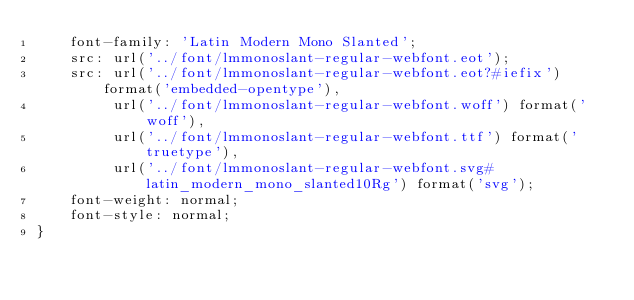Convert code to text. <code><loc_0><loc_0><loc_500><loc_500><_CSS_>    font-family: 'Latin Modern Mono Slanted';
    src: url('../font/lmmonoslant-regular-webfont.eot');
    src: url('../font/lmmonoslant-regular-webfont.eot?#iefix') format('embedded-opentype'),
         url('../font/lmmonoslant-regular-webfont.woff') format('woff'),
         url('../font/lmmonoslant-regular-webfont.ttf') format('truetype'),
         url('../font/lmmonoslant-regular-webfont.svg#latin_modern_mono_slanted10Rg') format('svg');
    font-weight: normal;
    font-style: normal;
}
</code> 